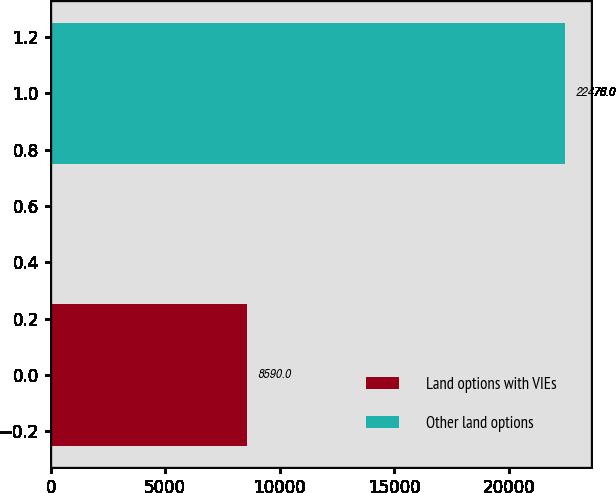<chart> <loc_0><loc_0><loc_500><loc_500><bar_chart><fcel>Land options with VIEs<fcel>Other land options<nl><fcel>8590<fcel>22476<nl></chart> 